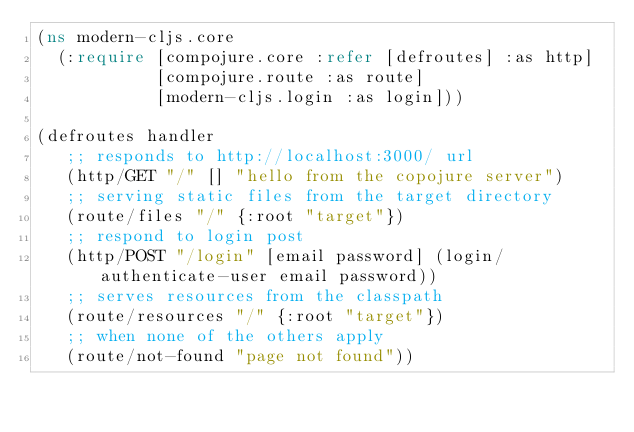<code> <loc_0><loc_0><loc_500><loc_500><_Clojure_>(ns modern-cljs.core
  (:require [compojure.core :refer [defroutes] :as http]
            [compojure.route :as route]
            [modern-cljs.login :as login]))

(defroutes handler
   ;; responds to http://localhost:3000/ url
   (http/GET "/" [] "hello from the copojure server")
   ;; serving static files from the target directory
   (route/files "/" {:root "target"})
   ;; respond to login post
   (http/POST "/login" [email password] (login/authenticate-user email password))
   ;; serves resources from the classpath
   (route/resources "/" {:root "target"})
   ;; when none of the others apply
   (route/not-found "page not found"))
</code> 